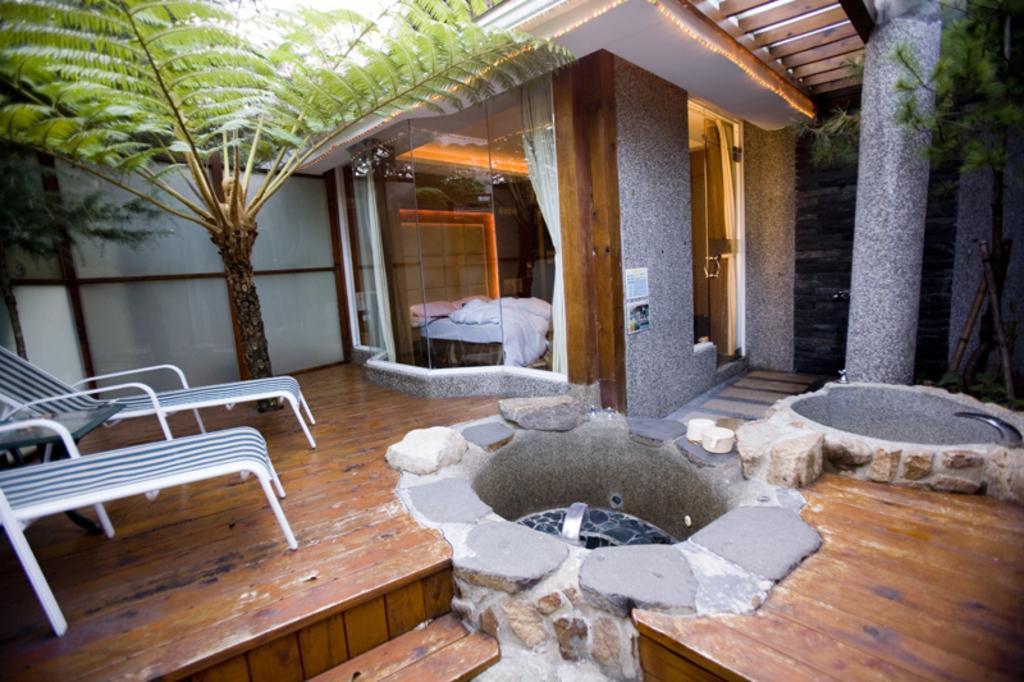In one or two sentences, can you explain what this image depicts? In this image I can see few chairs and a table on the left side. On the both side of this image I can see few trees and in the centre I can see a bed, few curtains and a door. 